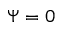Convert formula to latex. <formula><loc_0><loc_0><loc_500><loc_500>\Psi = 0</formula> 